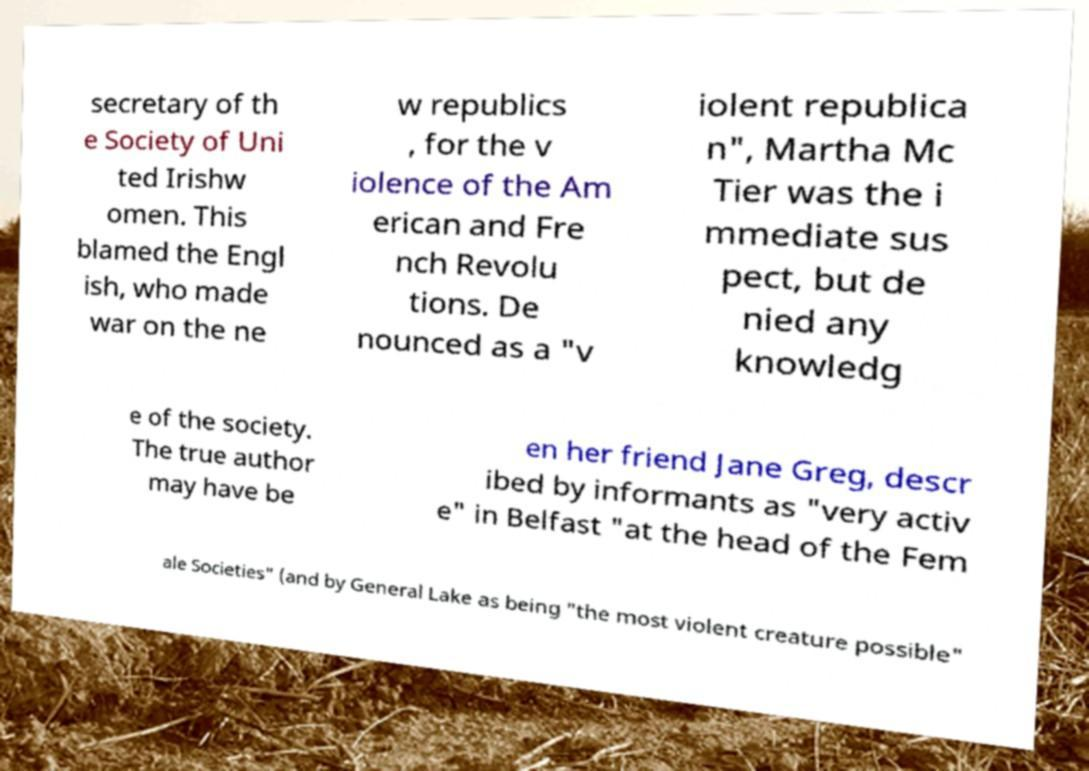I need the written content from this picture converted into text. Can you do that? secretary of th e Society of Uni ted Irishw omen. This blamed the Engl ish, who made war on the ne w republics , for the v iolence of the Am erican and Fre nch Revolu tions. De nounced as a "v iolent republica n", Martha Mc Tier was the i mmediate sus pect, but de nied any knowledg e of the society. The true author may have be en her friend Jane Greg, descr ibed by informants as "very activ e" in Belfast "at the head of the Fem ale Societies" (and by General Lake as being "the most violent creature possible" 